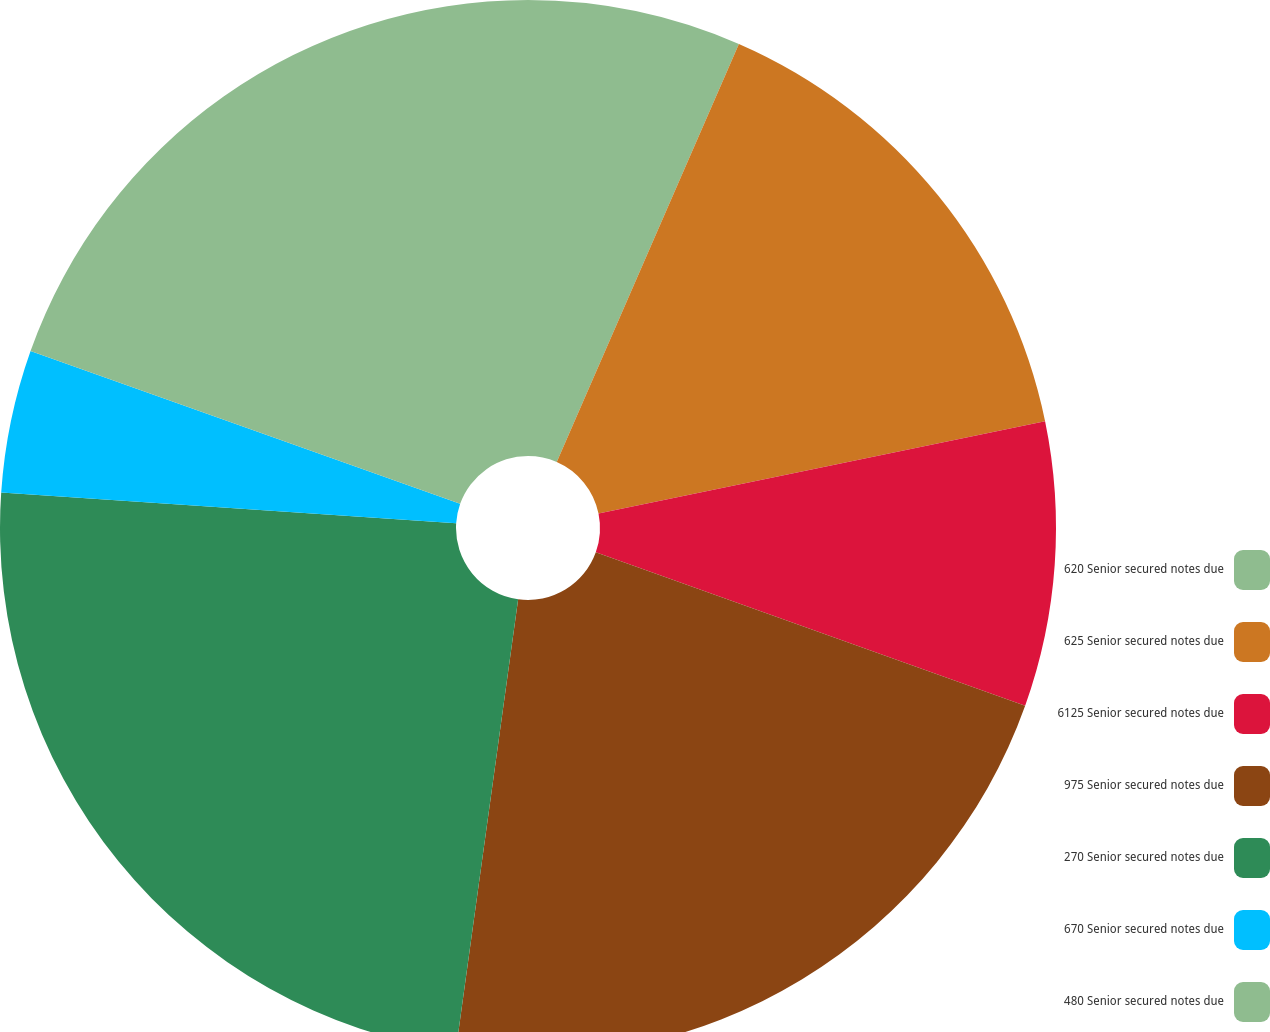Convert chart to OTSL. <chart><loc_0><loc_0><loc_500><loc_500><pie_chart><fcel>620 Senior secured notes due<fcel>625 Senior secured notes due<fcel>6125 Senior secured notes due<fcel>975 Senior secured notes due<fcel>270 Senior secured notes due<fcel>670 Senior secured notes due<fcel>480 Senior secured notes due<nl><fcel>6.54%<fcel>15.22%<fcel>8.71%<fcel>21.72%<fcel>23.89%<fcel>4.37%<fcel>19.56%<nl></chart> 